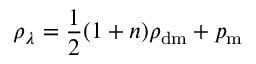<formula> <loc_0><loc_0><loc_500><loc_500>\rho _ { \lambda } = { \frac { 1 } { 2 } } ( 1 + n ) \rho _ { d m } + p _ { m }</formula> 